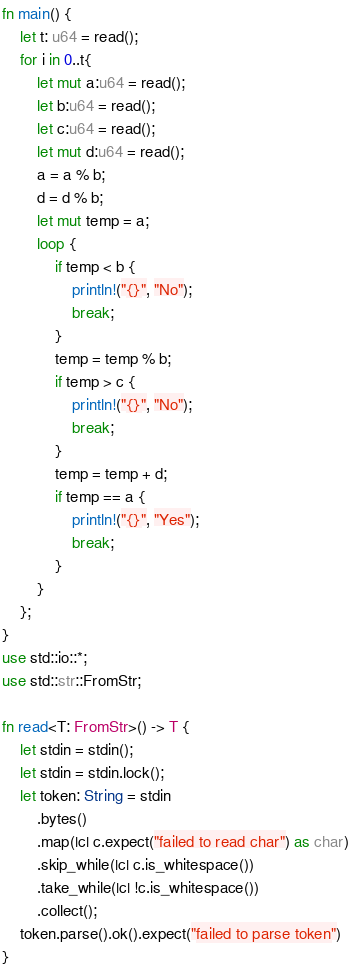Convert code to text. <code><loc_0><loc_0><loc_500><loc_500><_Rust_>fn main() {
    let t: u64 = read();
    for i in 0..t{
        let mut a:u64 = read();
        let b:u64 = read();
        let c:u64 = read();
        let mut d:u64 = read();
        a = a % b;
        d = d % b;
        let mut temp = a;
        loop {
            if temp < b {
                println!("{}", "No");
                break;
            }
            temp = temp % b;
            if temp > c {
                println!("{}", "No");
                break;
            }
            temp = temp + d;
            if temp == a {
                println!("{}", "Yes");
                break;
            }
        }
    };
}
use std::io::*;
use std::str::FromStr;

fn read<T: FromStr>() -> T {
    let stdin = stdin();
    let stdin = stdin.lock();
    let token: String = stdin
        .bytes()
        .map(|c| c.expect("failed to read char") as char) 
        .skip_while(|c| c.is_whitespace())
        .take_while(|c| !c.is_whitespace())
        .collect();
    token.parse().ok().expect("failed to parse token")
}</code> 